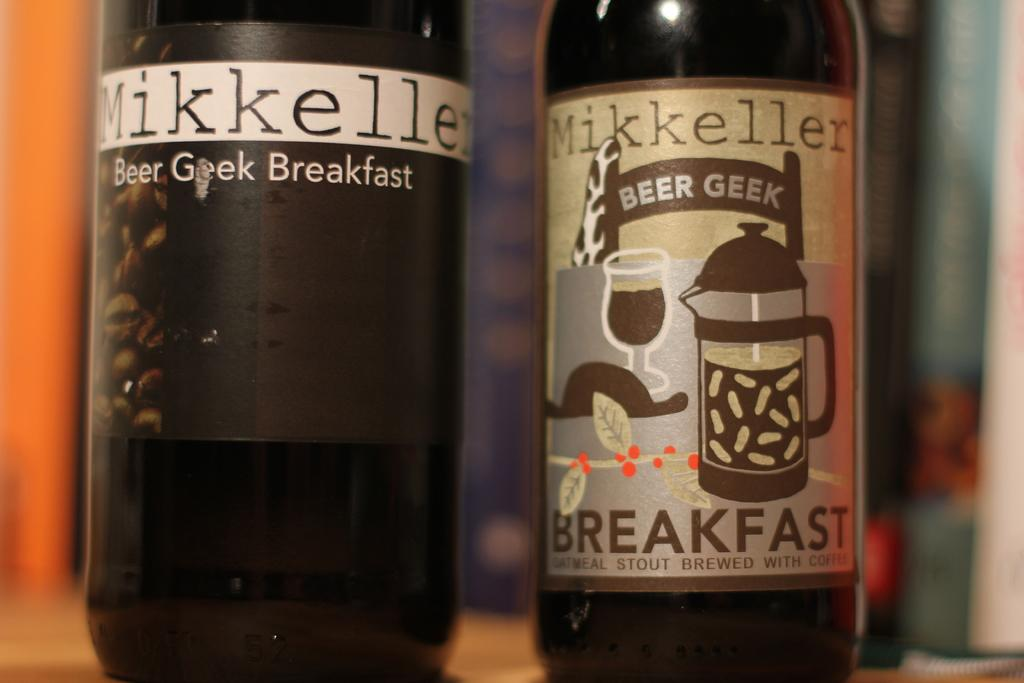<image>
Write a terse but informative summary of the picture. Two bottles of beer laballed mikkeller, one with breakfast on it. 